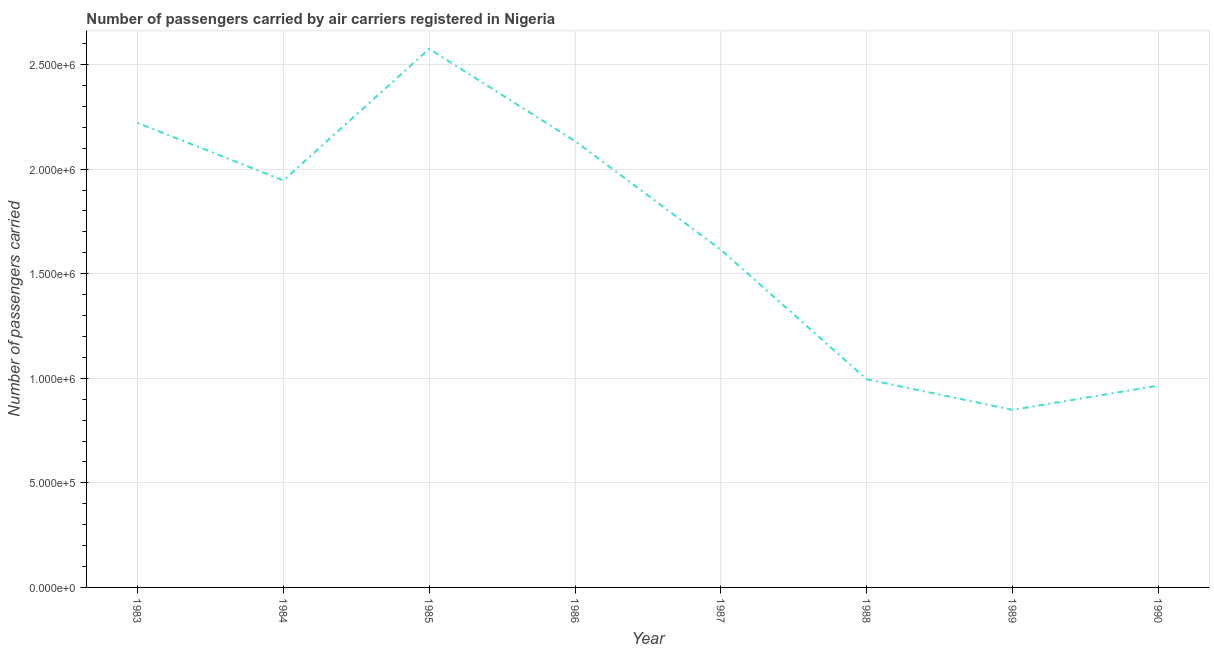What is the number of passengers carried in 1986?
Provide a succinct answer. 2.13e+06. Across all years, what is the maximum number of passengers carried?
Make the answer very short. 2.58e+06. Across all years, what is the minimum number of passengers carried?
Provide a short and direct response. 8.49e+05. In which year was the number of passengers carried maximum?
Offer a very short reply. 1985. In which year was the number of passengers carried minimum?
Offer a terse response. 1989. What is the sum of the number of passengers carried?
Ensure brevity in your answer.  1.33e+07. What is the difference between the number of passengers carried in 1985 and 1989?
Offer a very short reply. 1.73e+06. What is the average number of passengers carried per year?
Provide a short and direct response. 1.66e+06. What is the median number of passengers carried?
Ensure brevity in your answer.  1.78e+06. In how many years, is the number of passengers carried greater than 2200000 ?
Your answer should be very brief. 2. Do a majority of the years between 1987 and 1988 (inclusive) have number of passengers carried greater than 300000 ?
Give a very brief answer. Yes. What is the ratio of the number of passengers carried in 1984 to that in 1989?
Ensure brevity in your answer.  2.29. Is the number of passengers carried in 1984 less than that in 1987?
Your response must be concise. No. What is the difference between the highest and the second highest number of passengers carried?
Offer a terse response. 3.54e+05. What is the difference between the highest and the lowest number of passengers carried?
Offer a very short reply. 1.73e+06. Does the number of passengers carried monotonically increase over the years?
Keep it short and to the point. No. How many lines are there?
Keep it short and to the point. 1. Are the values on the major ticks of Y-axis written in scientific E-notation?
Give a very brief answer. Yes. Does the graph contain any zero values?
Give a very brief answer. No. What is the title of the graph?
Offer a very short reply. Number of passengers carried by air carriers registered in Nigeria. What is the label or title of the X-axis?
Keep it short and to the point. Year. What is the label or title of the Y-axis?
Provide a succinct answer. Number of passengers carried. What is the Number of passengers carried in 1983?
Your answer should be compact. 2.22e+06. What is the Number of passengers carried in 1984?
Your response must be concise. 1.95e+06. What is the Number of passengers carried in 1985?
Provide a short and direct response. 2.58e+06. What is the Number of passengers carried in 1986?
Provide a short and direct response. 2.13e+06. What is the Number of passengers carried of 1987?
Offer a very short reply. 1.61e+06. What is the Number of passengers carried of 1988?
Offer a terse response. 9.95e+05. What is the Number of passengers carried of 1989?
Your response must be concise. 8.49e+05. What is the Number of passengers carried of 1990?
Ensure brevity in your answer.  9.65e+05. What is the difference between the Number of passengers carried in 1983 and 1984?
Give a very brief answer. 2.75e+05. What is the difference between the Number of passengers carried in 1983 and 1985?
Keep it short and to the point. -3.54e+05. What is the difference between the Number of passengers carried in 1983 and 1986?
Offer a terse response. 8.73e+04. What is the difference between the Number of passengers carried in 1983 and 1987?
Keep it short and to the point. 6.07e+05. What is the difference between the Number of passengers carried in 1983 and 1988?
Keep it short and to the point. 1.23e+06. What is the difference between the Number of passengers carried in 1983 and 1989?
Offer a terse response. 1.37e+06. What is the difference between the Number of passengers carried in 1983 and 1990?
Provide a short and direct response. 1.26e+06. What is the difference between the Number of passengers carried in 1984 and 1985?
Your answer should be compact. -6.29e+05. What is the difference between the Number of passengers carried in 1984 and 1986?
Give a very brief answer. -1.88e+05. What is the difference between the Number of passengers carried in 1984 and 1987?
Give a very brief answer. 3.32e+05. What is the difference between the Number of passengers carried in 1984 and 1988?
Give a very brief answer. 9.51e+05. What is the difference between the Number of passengers carried in 1984 and 1989?
Give a very brief answer. 1.10e+06. What is the difference between the Number of passengers carried in 1984 and 1990?
Make the answer very short. 9.81e+05. What is the difference between the Number of passengers carried in 1985 and 1986?
Provide a succinct answer. 4.41e+05. What is the difference between the Number of passengers carried in 1985 and 1987?
Your answer should be compact. 9.61e+05. What is the difference between the Number of passengers carried in 1985 and 1988?
Ensure brevity in your answer.  1.58e+06. What is the difference between the Number of passengers carried in 1985 and 1989?
Your response must be concise. 1.73e+06. What is the difference between the Number of passengers carried in 1985 and 1990?
Make the answer very short. 1.61e+06. What is the difference between the Number of passengers carried in 1986 and 1987?
Offer a very short reply. 5.20e+05. What is the difference between the Number of passengers carried in 1986 and 1988?
Your response must be concise. 1.14e+06. What is the difference between the Number of passengers carried in 1986 and 1989?
Make the answer very short. 1.29e+06. What is the difference between the Number of passengers carried in 1986 and 1990?
Keep it short and to the point. 1.17e+06. What is the difference between the Number of passengers carried in 1987 and 1988?
Your response must be concise. 6.19e+05. What is the difference between the Number of passengers carried in 1987 and 1989?
Provide a succinct answer. 7.66e+05. What is the difference between the Number of passengers carried in 1987 and 1990?
Offer a very short reply. 6.50e+05. What is the difference between the Number of passengers carried in 1988 and 1989?
Your answer should be very brief. 1.46e+05. What is the difference between the Number of passengers carried in 1988 and 1990?
Keep it short and to the point. 3.02e+04. What is the difference between the Number of passengers carried in 1989 and 1990?
Your answer should be compact. -1.16e+05. What is the ratio of the Number of passengers carried in 1983 to that in 1984?
Give a very brief answer. 1.14. What is the ratio of the Number of passengers carried in 1983 to that in 1985?
Your answer should be compact. 0.86. What is the ratio of the Number of passengers carried in 1983 to that in 1986?
Ensure brevity in your answer.  1.04. What is the ratio of the Number of passengers carried in 1983 to that in 1987?
Offer a very short reply. 1.38. What is the ratio of the Number of passengers carried in 1983 to that in 1988?
Give a very brief answer. 2.23. What is the ratio of the Number of passengers carried in 1983 to that in 1989?
Provide a succinct answer. 2.62. What is the ratio of the Number of passengers carried in 1983 to that in 1990?
Keep it short and to the point. 2.3. What is the ratio of the Number of passengers carried in 1984 to that in 1985?
Ensure brevity in your answer.  0.76. What is the ratio of the Number of passengers carried in 1984 to that in 1986?
Provide a succinct answer. 0.91. What is the ratio of the Number of passengers carried in 1984 to that in 1987?
Your response must be concise. 1.21. What is the ratio of the Number of passengers carried in 1984 to that in 1988?
Offer a terse response. 1.96. What is the ratio of the Number of passengers carried in 1984 to that in 1989?
Offer a terse response. 2.29. What is the ratio of the Number of passengers carried in 1984 to that in 1990?
Provide a succinct answer. 2.02. What is the ratio of the Number of passengers carried in 1985 to that in 1986?
Your answer should be compact. 1.21. What is the ratio of the Number of passengers carried in 1985 to that in 1987?
Give a very brief answer. 1.59. What is the ratio of the Number of passengers carried in 1985 to that in 1988?
Offer a terse response. 2.59. What is the ratio of the Number of passengers carried in 1985 to that in 1989?
Offer a very short reply. 3.03. What is the ratio of the Number of passengers carried in 1985 to that in 1990?
Provide a succinct answer. 2.67. What is the ratio of the Number of passengers carried in 1986 to that in 1987?
Give a very brief answer. 1.32. What is the ratio of the Number of passengers carried in 1986 to that in 1988?
Offer a terse response. 2.15. What is the ratio of the Number of passengers carried in 1986 to that in 1989?
Offer a very short reply. 2.51. What is the ratio of the Number of passengers carried in 1986 to that in 1990?
Keep it short and to the point. 2.21. What is the ratio of the Number of passengers carried in 1987 to that in 1988?
Keep it short and to the point. 1.62. What is the ratio of the Number of passengers carried in 1987 to that in 1989?
Make the answer very short. 1.9. What is the ratio of the Number of passengers carried in 1987 to that in 1990?
Offer a terse response. 1.67. What is the ratio of the Number of passengers carried in 1988 to that in 1989?
Make the answer very short. 1.17. What is the ratio of the Number of passengers carried in 1988 to that in 1990?
Your answer should be compact. 1.03. What is the ratio of the Number of passengers carried in 1989 to that in 1990?
Your answer should be compact. 0.88. 